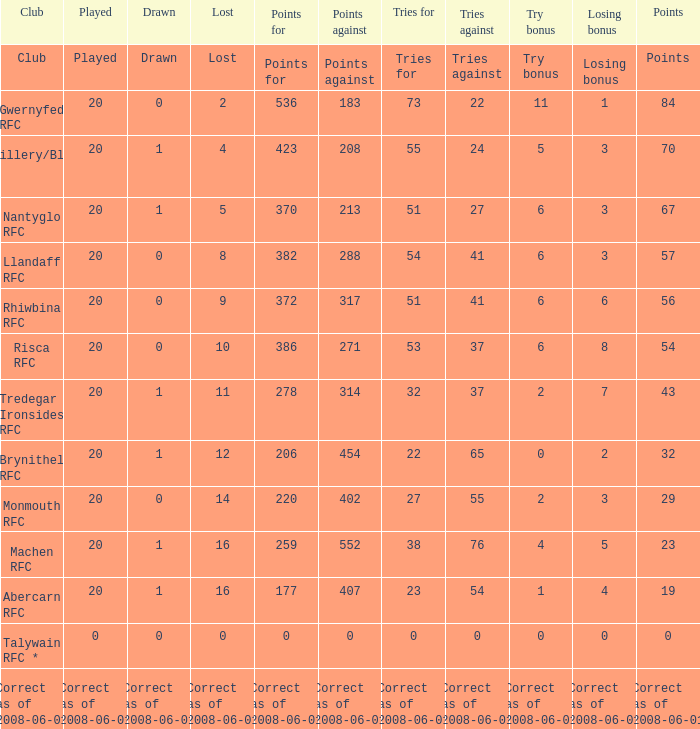Name the tries when tries against were 41, try bonus was 6, and had 317 points. 51.0. 